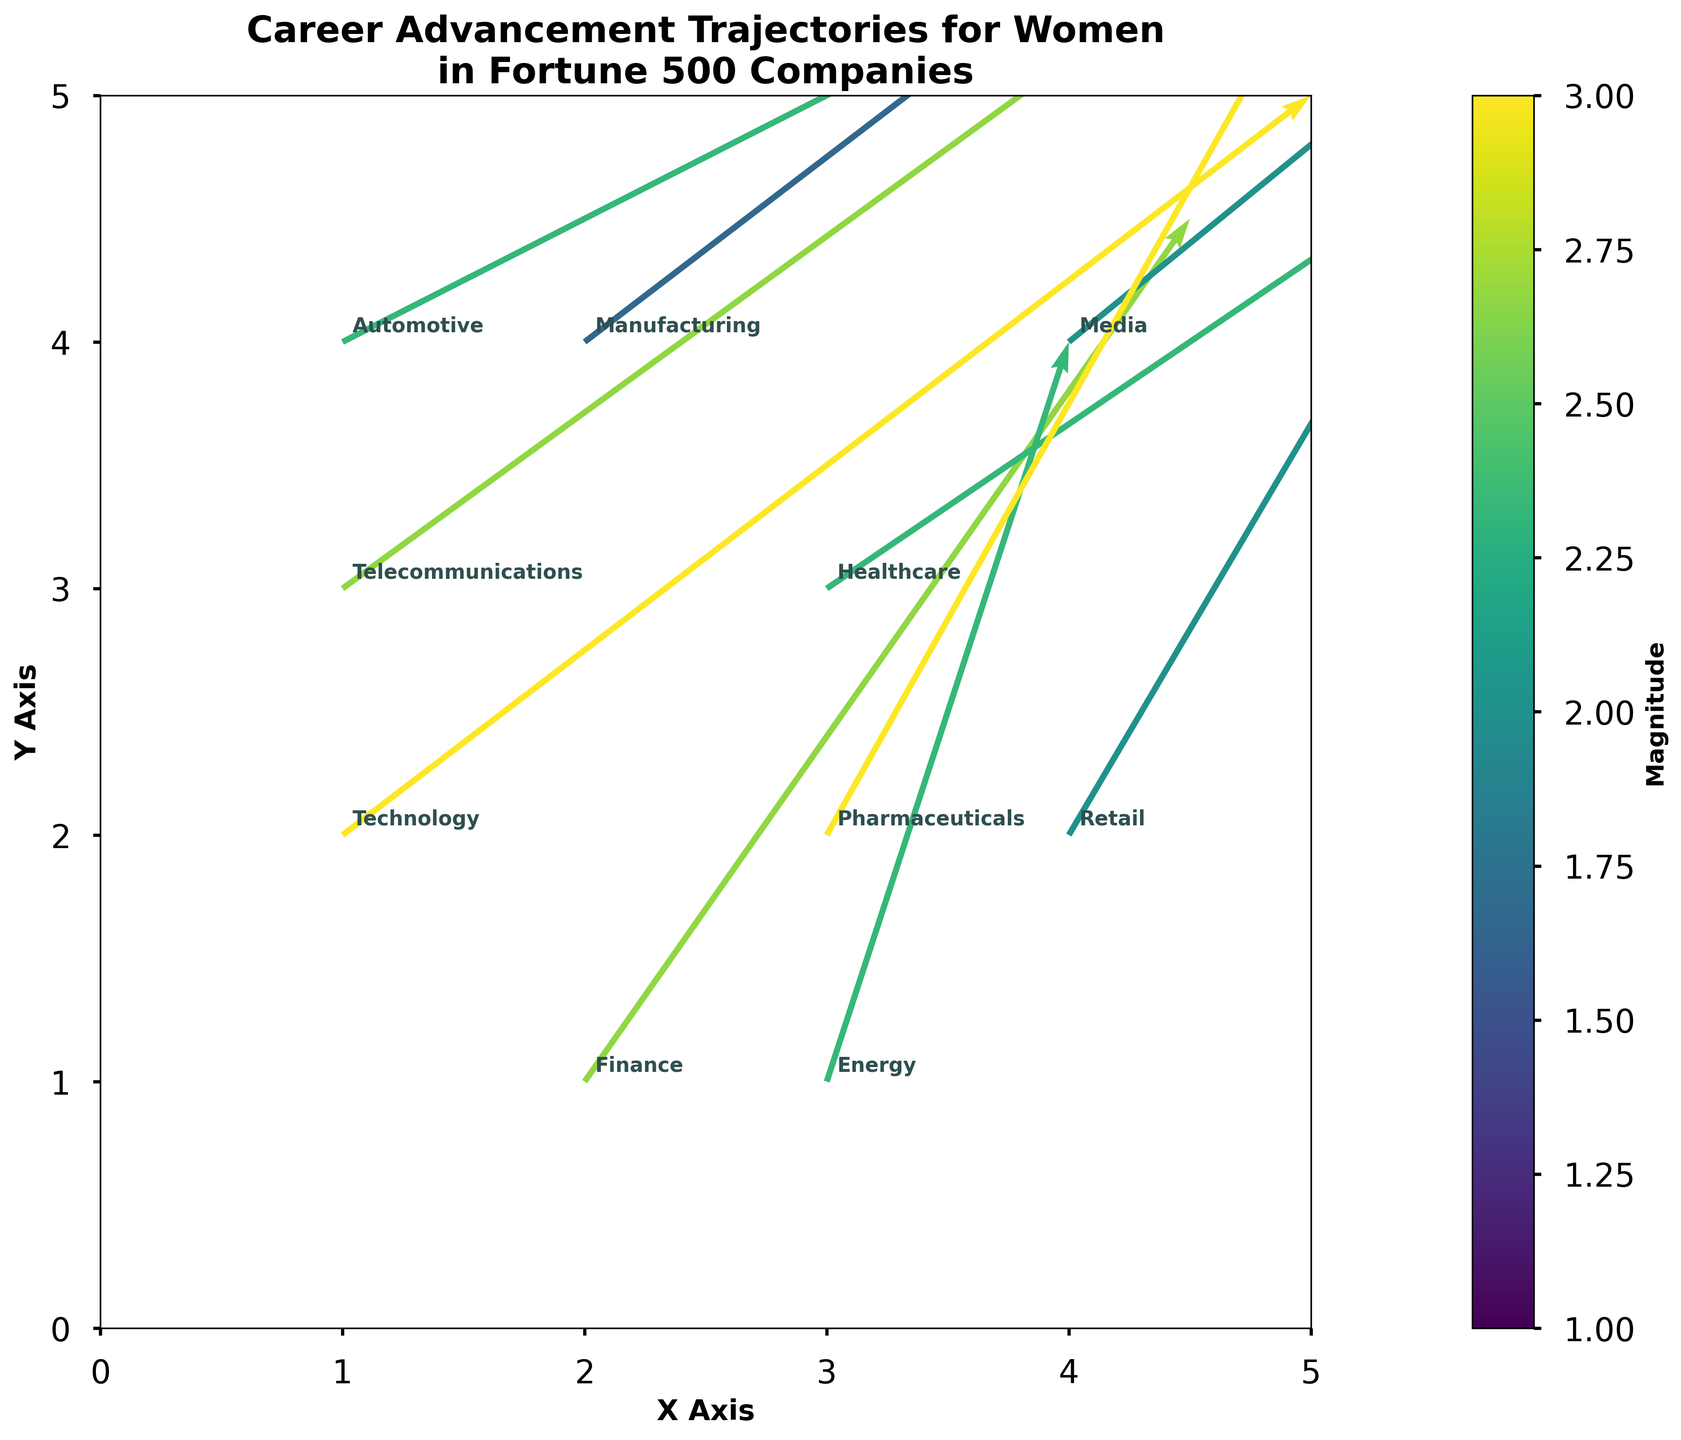what is the title of the figure? The title is found at the top center of the figure and usually summarizes the main theme of the plot.
Answer: Career Advancement Trajectories for Women in Fortune 500 Companies what do the different colors indicate in the figure? The color gradient in the figure represents the magnitude of the progress, where varied intensities indicate different magnitude values. This is detailed in the color bar on the side labeled 'Magnitude'.
Answer: Magnitude of progress which industry shows the smallest magnitude of progress? By observing the shortest and least intense arrow on the quiver plot, we can identify the smallest magnitude. The color bar can help confirm this.
Answer: Manufacturing how many industries are represented in the figure? The number of industries can be counted based on the annotations or labels next to the arrows on the quiver plot.
Answer: 10 which industry is located at position (4, 2) on the X-Y plane? We can look at the figure and find the label or annotation placed at (4, 2).
Answer: Retail which industry has a higher magnitude of progress, Technology or Retail? By comparing the lengths and colors of the arrows representing Technology and Retail, we can determine which has a higher magnitude.
Answer: Technology compare the direction of progress between Finance and Energy industries. Which one has a steeper trajectory? To determine the steeper trajectory, we compare the angle formed by the direction vectors of each industry with respect to the X-axis.
Answer: Energy what is the average magnitude of progress across all industries? Sum up the magnitudes of each industry and then divide by the total number of industries: (3 + 2.5 + 2 + 1.5 + 1 + 2 + 2.5 + 1.5 + 2 + 3) / 10.
Answer: 2 identify the industry with coordinates (3, 3). What is its direction of progress vector? Look at the label located at coordinates (3, 3) on the X-Y axis, then identify its direction vector (U and V components).
Answer: Healthcare, (0.6, 0.4) which industry has a direction vector closest to (0.7, 0.5)? Compare all direction vectors provided in the data and see which one is closest to (0.7, 0.5).
Answer: Telecommunications 